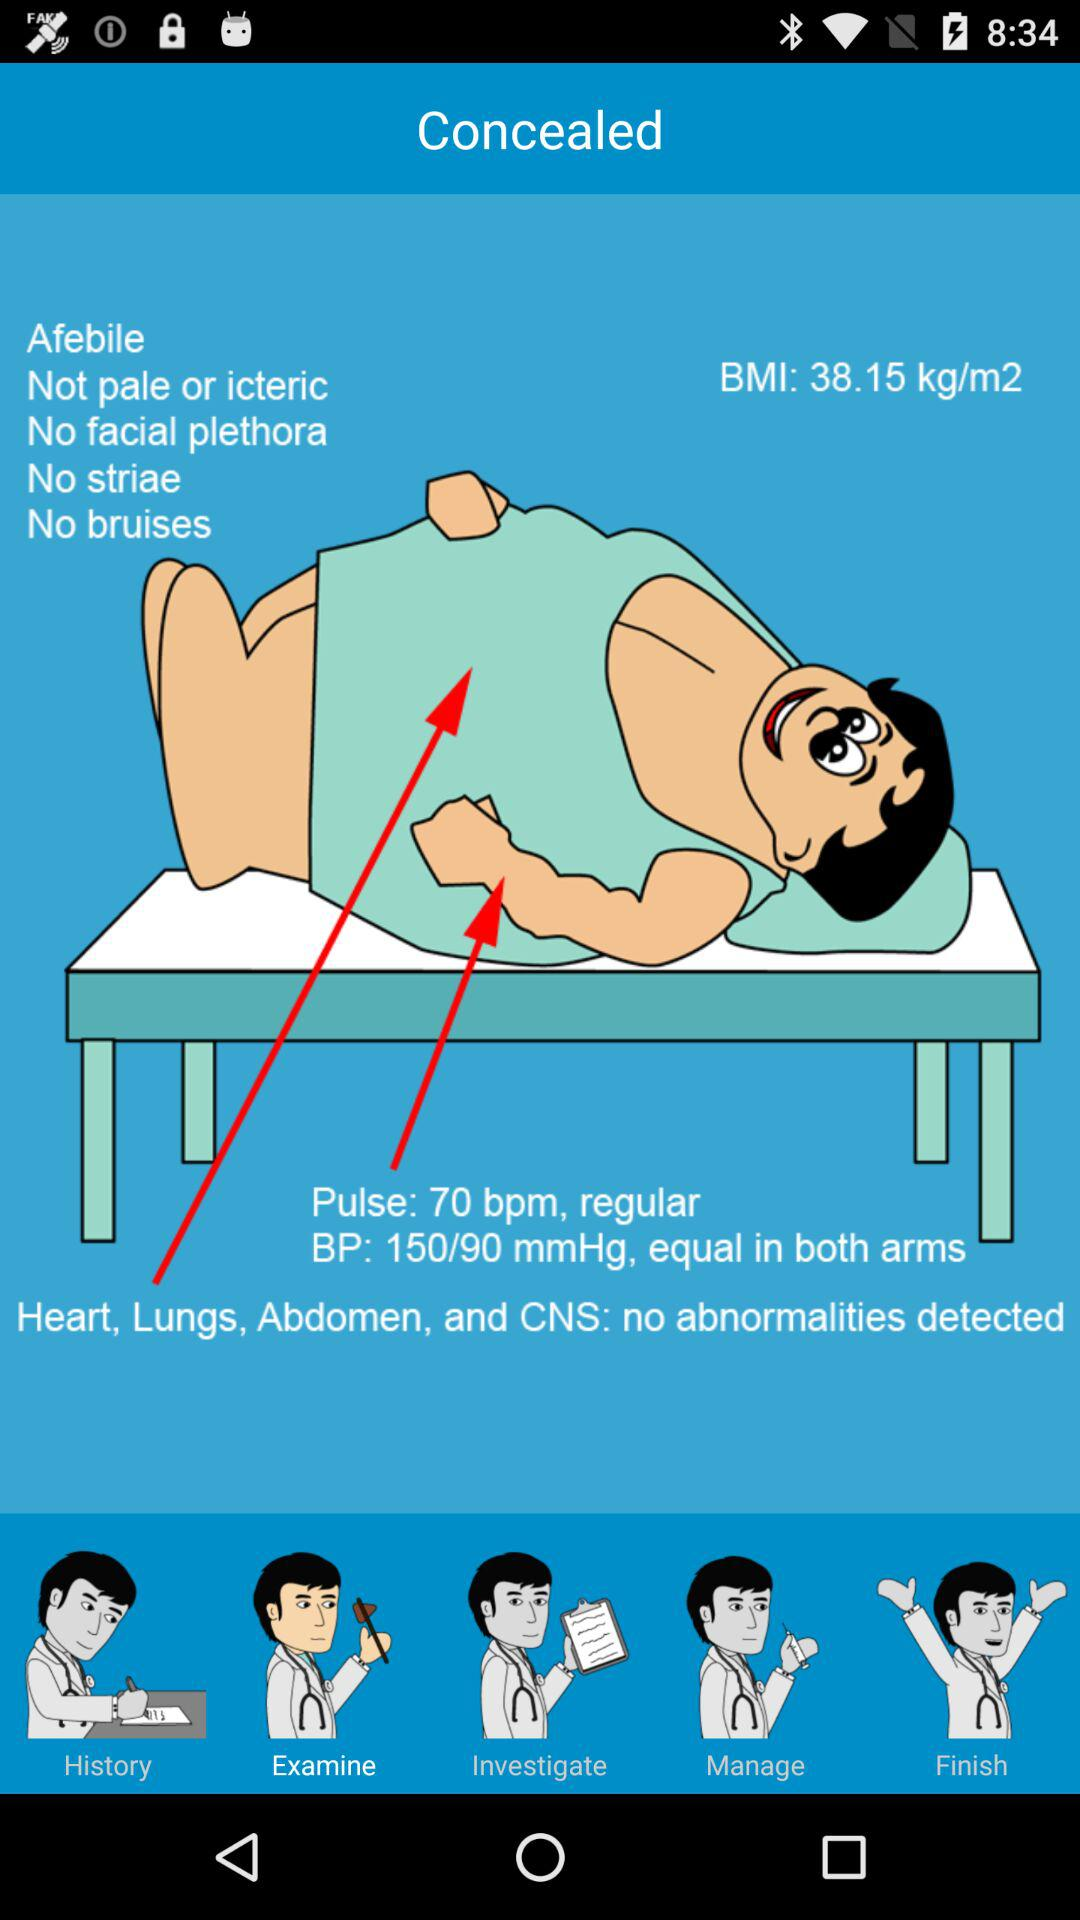What is the blood pressure? The blood pressure is 150/90 mmHg. 